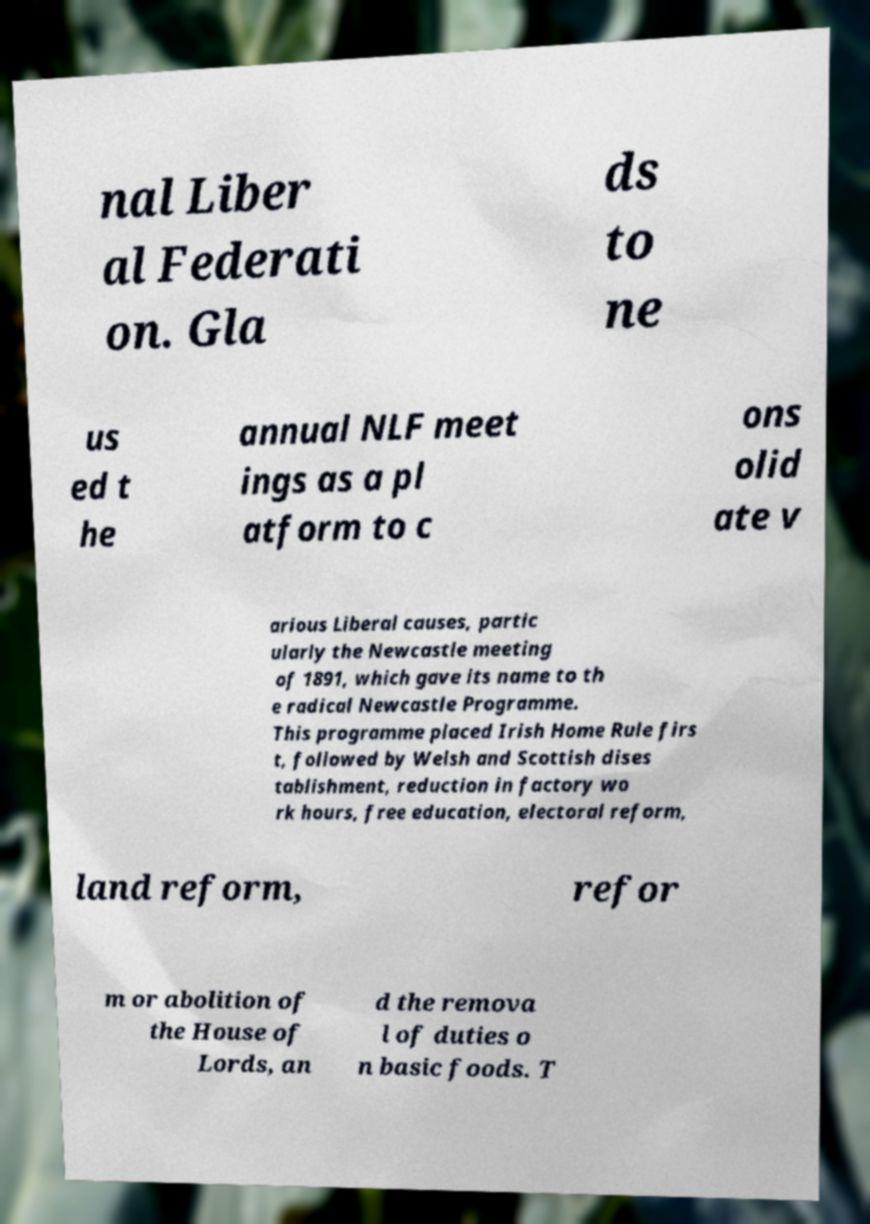Could you extract and type out the text from this image? nal Liber al Federati on. Gla ds to ne us ed t he annual NLF meet ings as a pl atform to c ons olid ate v arious Liberal causes, partic ularly the Newcastle meeting of 1891, which gave its name to th e radical Newcastle Programme. This programme placed Irish Home Rule firs t, followed by Welsh and Scottish dises tablishment, reduction in factory wo rk hours, free education, electoral reform, land reform, refor m or abolition of the House of Lords, an d the remova l of duties o n basic foods. T 